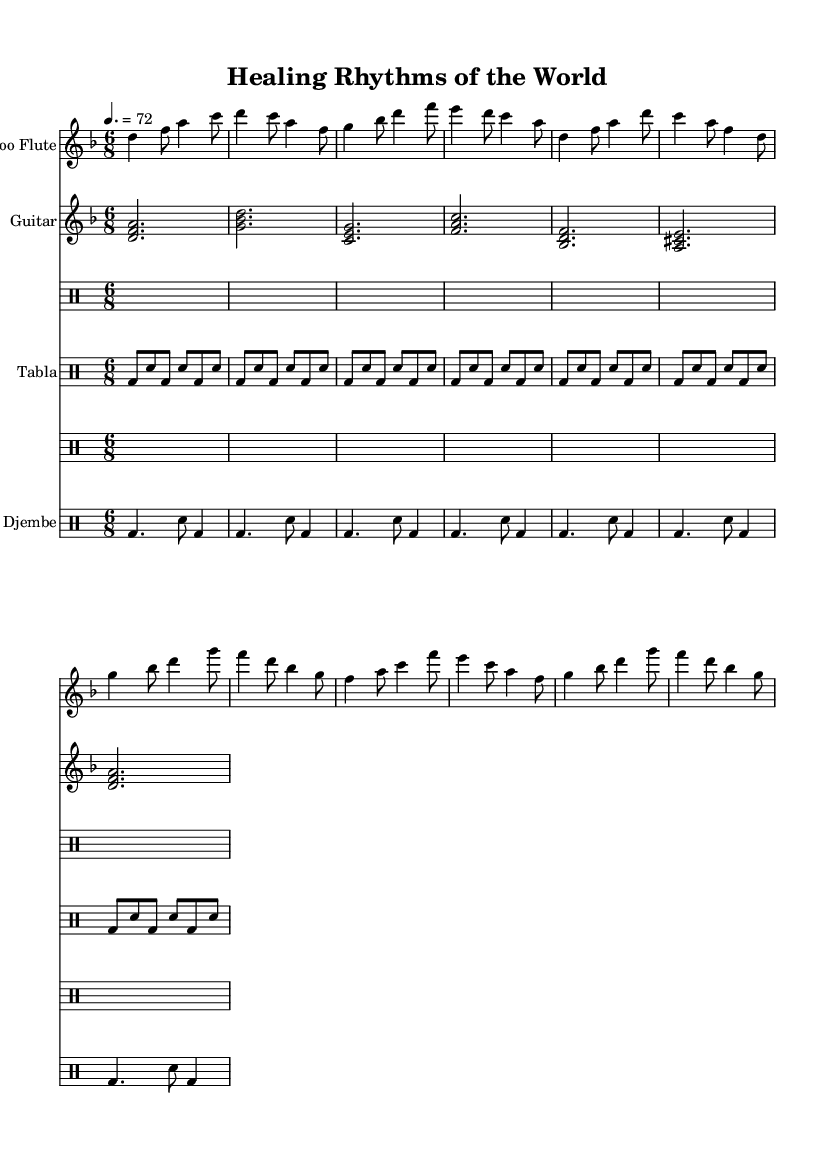What is the key signature of this music? The key signature is D minor, which has one flat (B flat). This can be determined by checking the key signature section at the beginning of the sheet music where the flat is indicated.
Answer: D minor What is the time signature of this music? The time signature is 6/8, which can be found at the beginning of the sheet music. It indicates that there are six eighth notes per measure.
Answer: 6/8 What is the tempo marking of this music? The tempo marking indicates a speed of 72 beats per minute, as shown at the top of the sheet music written as "4. = 72". This specifies how fast the music should be played.
Answer: 72 How many measures are there in the flute part? To find the number of measures, one counts each bar in the flute staff. There are 12 measures indicated by the clef and the bar lines between the notes.
Answer: 12 What instruments are featured in this fusion piece? The instruments listed in the score indicate the featured instruments are "Bamboo Flute," "Guitar," "Tabla," and "Djembe." This indicates the fusion of various cultural sounds typically associated with traditional healing practices.
Answer: Bamboo Flute, Guitar, Tabla, Djembe What rhythmic style is predominantly used in the Tabla part? The predominant rhythmic pattern for the Tabla is a repetitive motif, using a combination of bass and snare strokes in a rhythmic pattern. This is typical of traditional Asian music styles emphasizing fast-paced, intricate rhythms.
Answer: Repetitive motif What is the overall cultural influence of the music? The title "Healing Rhythms of the World" suggests a fusion inspired by global traditional healing practices. The involvement of instruments like the Djembe and Tabla highlights African and South Asian cultural influences, respectively.
Answer: Global traditional healing practices 